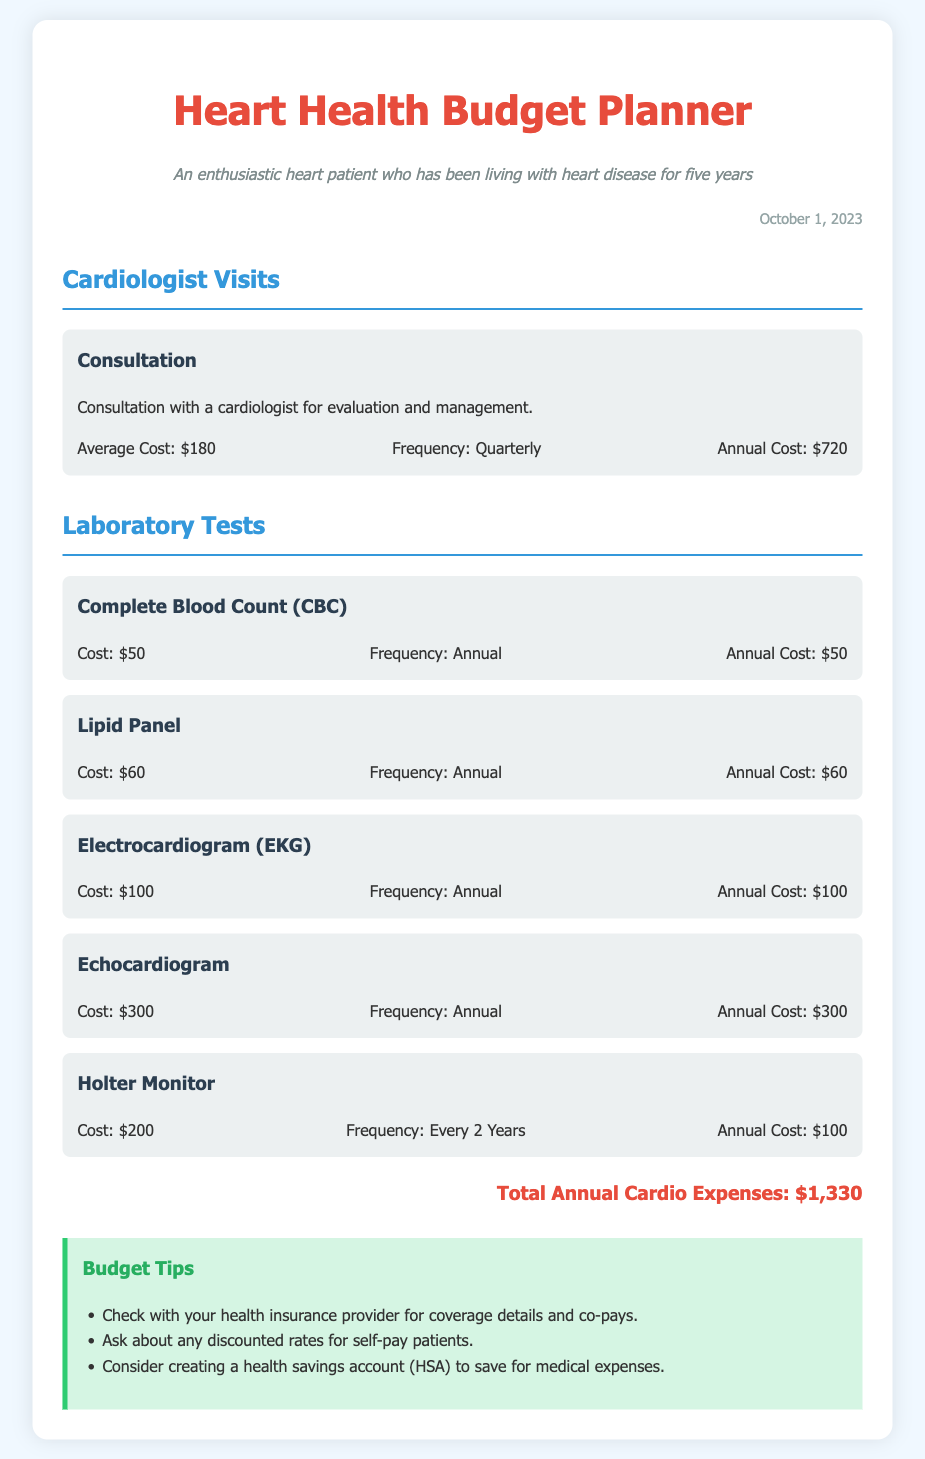What is the average cost of a cardiologist consultation? The average cost of a cardiologist consultation is listed under the consultation expense item, which is $180.
Answer: $180 How often do you visit the cardiologist? The document states the frequency of cardiologist visits is quarterly, meaning four times a year.
Answer: Quarterly What is the total annual cost for the consultation? The total annual cost is calculated based on the average cost per consultation and the frequency, which sums up to $720.
Answer: $720 How much does a Lipid Panel test cost? The document specifies the cost of a Lipid Panel test, which is $60.
Answer: $60 What is the annual cost for Holter Monitor? The document indicates the annual cost for a Holter Monitor, which is $100 as it is done every two years.
Answer: $100 What is the total annual expense for cardiology-related services? The total is derived by adding all individual annual costs, which results in $1,330.
Answer: $1,330 What recommendation is given regarding health savings? The document suggests creating a health savings account (HSA) for medical expenses as a budget tip.
Answer: Health savings account (HSA) How much does an Echocardiogram cost? The cost of an Echocardiogram is given in the document as $300.
Answer: $300 What is the frequency of the Complete Blood Count test? The frequency for the Complete Blood Count test is mentioned as annual.
Answer: Annual 